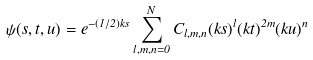<formula> <loc_0><loc_0><loc_500><loc_500>\psi ( s , t , u ) = e ^ { - ( 1 / 2 ) k s } \sum _ { l , m , n = 0 } ^ { N } C _ { l , m , n } ( k s ) ^ { l } ( k t ) ^ { 2 m } ( k u ) ^ { n }</formula> 